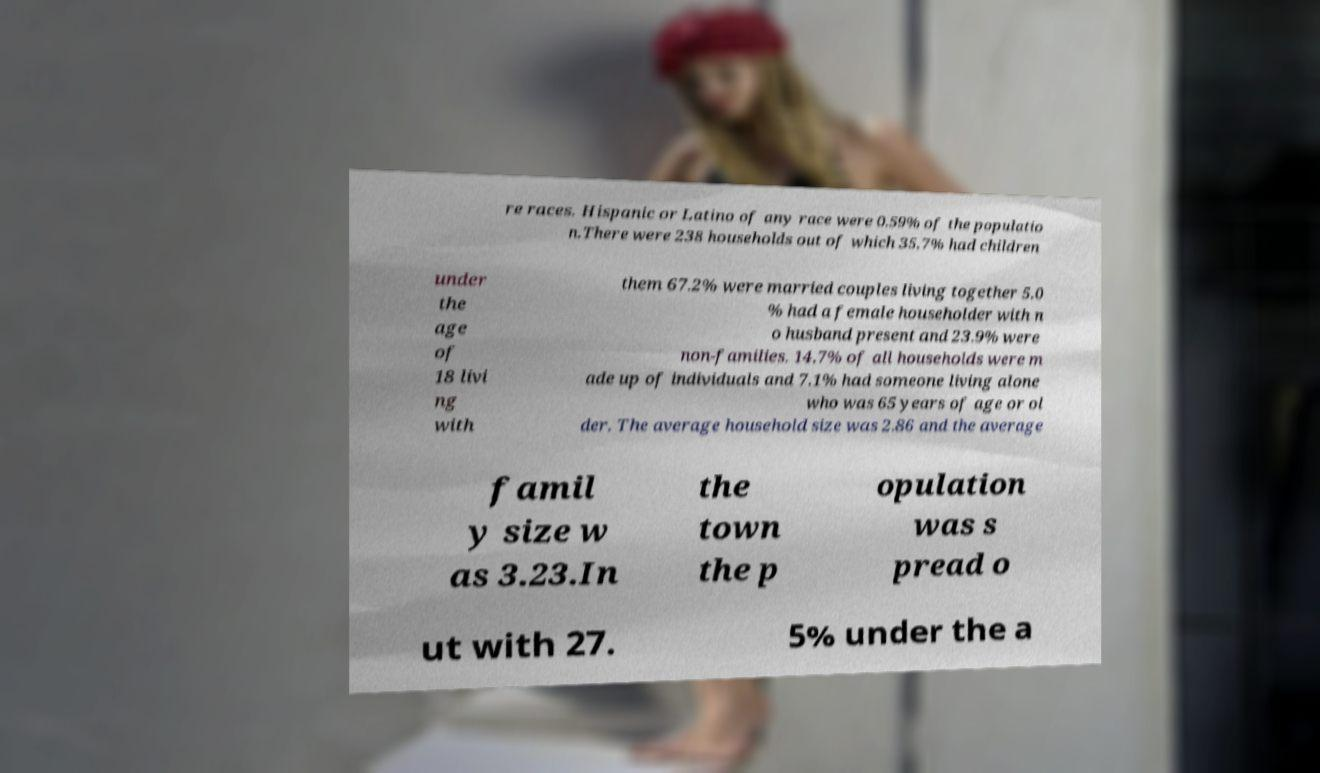There's text embedded in this image that I need extracted. Can you transcribe it verbatim? re races. Hispanic or Latino of any race were 0.59% of the populatio n.There were 238 households out of which 35.7% had children under the age of 18 livi ng with them 67.2% were married couples living together 5.0 % had a female householder with n o husband present and 23.9% were non-families. 14.7% of all households were m ade up of individuals and 7.1% had someone living alone who was 65 years of age or ol der. The average household size was 2.86 and the average famil y size w as 3.23.In the town the p opulation was s pread o ut with 27. 5% under the a 